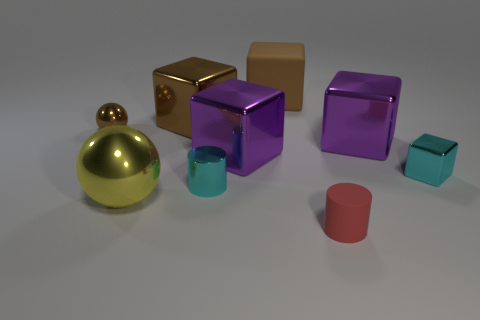Subtract all cyan blocks. How many blocks are left? 4 Subtract all cyan shiny blocks. How many blocks are left? 4 Subtract all red blocks. Subtract all purple cylinders. How many blocks are left? 5 Add 1 big metallic balls. How many objects exist? 10 Subtract all cubes. How many objects are left? 4 Add 8 tiny cylinders. How many tiny cylinders exist? 10 Subtract 1 cyan cubes. How many objects are left? 8 Subtract all tiny red metallic cubes. Subtract all big yellow objects. How many objects are left? 8 Add 7 red cylinders. How many red cylinders are left? 8 